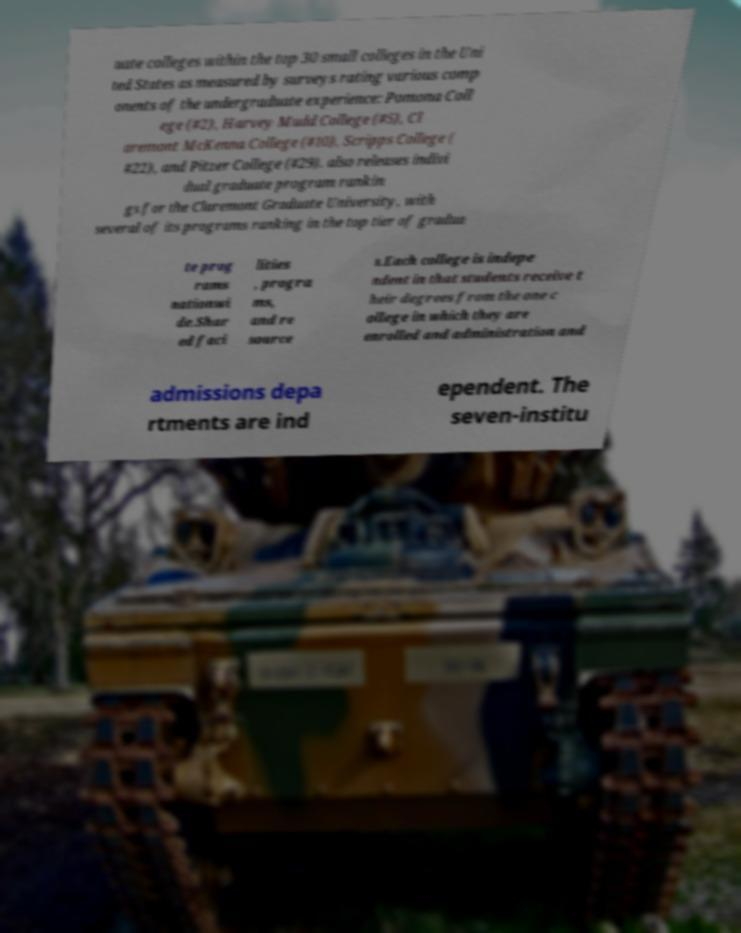Could you extract and type out the text from this image? uate colleges within the top 30 small colleges in the Uni ted States as measured by surveys rating various comp onents of the undergraduate experience: Pomona Coll ege (#2), Harvey Mudd College (#5), Cl aremont McKenna College (#10), Scripps College ( #22), and Pitzer College (#29). also releases indivi dual graduate program rankin gs for the Claremont Graduate University, with several of its programs ranking in the top tier of gradua te prog rams nationwi de.Shar ed faci lities , progra ms, and re source s.Each college is indepe ndent in that students receive t heir degrees from the one c ollege in which they are enrolled and administration and admissions depa rtments are ind ependent. The seven-institu 